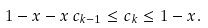<formula> <loc_0><loc_0><loc_500><loc_500>1 - x - x \, c _ { k - 1 } \leq c _ { k } \leq 1 - x .</formula> 